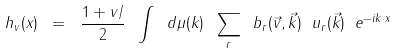Convert formula to latex. <formula><loc_0><loc_0><loc_500><loc_500>h _ { v } ( x ) \ = \ \frac { 1 + v { \slash } } { 2 } \ \int \ d { \mu } ( k ) \ \sum _ { r } \ b _ { r } ( \vec { v } , \vec { k } ) \ u _ { r } ( \vec { k } ) \ e ^ { - i k { \cdot } x }</formula> 